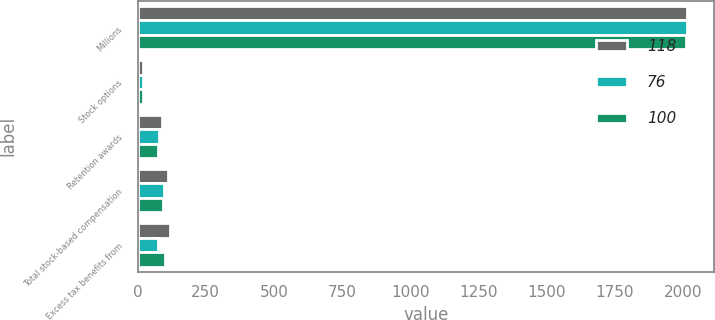<chart> <loc_0><loc_0><loc_500><loc_500><stacked_bar_chart><ecel><fcel>Millions<fcel>Stock options<fcel>Retention awards<fcel>Total stock-based compensation<fcel>Excess tax benefits from<nl><fcel>118<fcel>2014<fcel>21<fcel>91<fcel>112<fcel>118<nl><fcel>76<fcel>2013<fcel>19<fcel>79<fcel>98<fcel>76<nl><fcel>100<fcel>2012<fcel>18<fcel>75<fcel>93<fcel>100<nl></chart> 